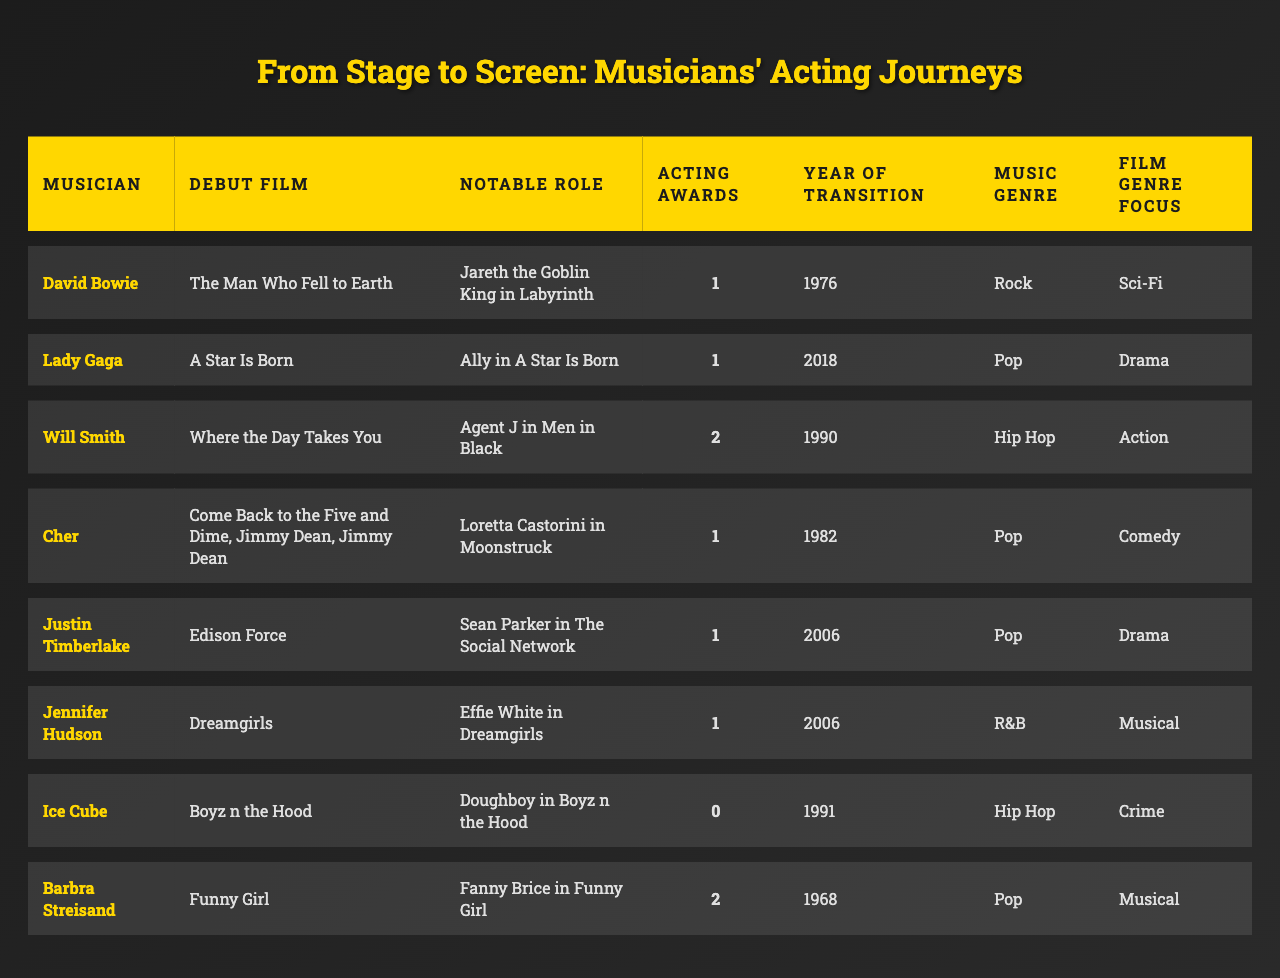What was the debut film for Lady Gaga? Looking at the table, under the column 'Debut Film', the row for Lady Gaga mentions "A Star Is Born".
Answer: A Star Is Born Which musician has the most awards for acting? By scanning the 'Awards for Acting' column, Will Smith has the highest count with 2 awards.
Answer: Will Smith How many musicians transitioned to acting in 2006? In the 'Year of Transition' column, I find two musicians, Justin Timberlake and Jennifer Hudson, listed for the year 2006.
Answer: 2 Which genres do Barbra Streisand and Ice Cube have in common? Looking at their 'Music Genre' column, both Barbra Streisand and Ice Cube fall under the 'Pop' genre.
Answer: Pop Is it true that Cher transitioned to acting before 1990? By checking the 'Year of Transition' column, Cher's year is 1982, which is before 1990, so the statement is true.
Answer: Yes What is the average number of acting awards across all musicians? To calculate the average, we sum the acting awards: (1 + 1 + 2 + 1 + 1 + 1 + 0 + 2) = 9 and divide by the number of musicians (8). This gives us an average of 9/8 = 1.125.
Answer: 1.125 Which musician transitioned to acting in the same year as Justin Timberlake? Looking at the 'Year of Transition', only Jennifer Hudson shares the year 2006 with Justin Timberlake.
Answer: Jennifer Hudson How many musicians have at least one acting award? By reviewing the 'Awards for Acting' column, I count six musicians with at least one award (1 or more), excluding Ice Cube who has zero.
Answer: 6 Who had the notable role of Jareth the Goblin King? Referring to the 'Notable Role' column, it indicates that David Bowie played Jareth the Goblin King.
Answer: David Bowie Which film genre is most common among these musicians' notable roles? Analyzing the 'Film Genre Focus', I notice that both 'Musical' and 'Drama' appear twice, but 'Drama' dominates as it's listed for Lady Gaga and Justin Timberlake.
Answer: Drama 